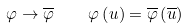Convert formula to latex. <formula><loc_0><loc_0><loc_500><loc_500>\varphi \rightarrow \overline { \varphi } \quad \varphi \left ( u \right ) = \overline { \varphi } \left ( \overline { u } \right )</formula> 